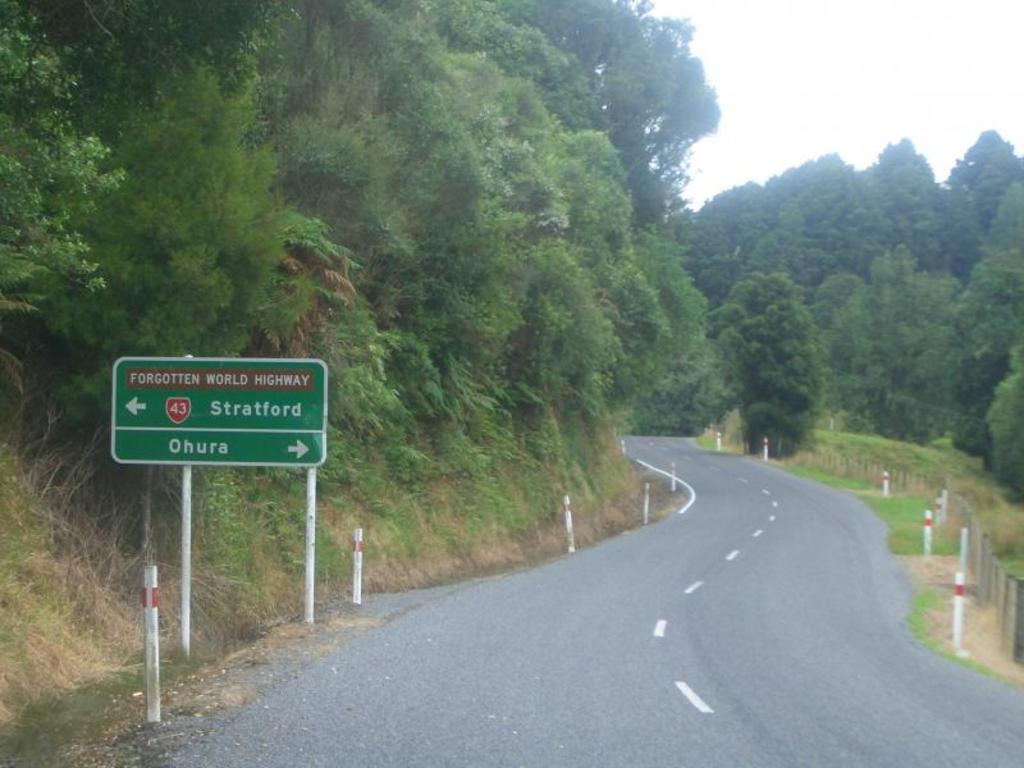<image>
Render a clear and concise summary of the photo. A winding road called Forgotten World Highway makes its way through the countryside. 